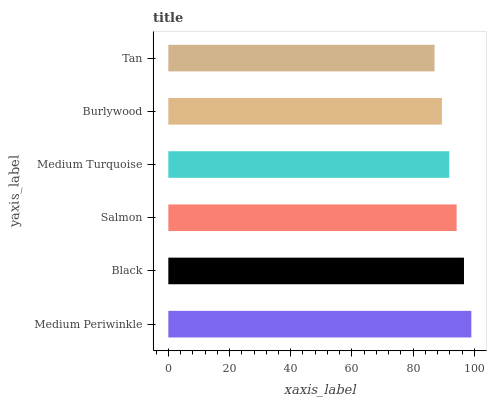Is Tan the minimum?
Answer yes or no. Yes. Is Medium Periwinkle the maximum?
Answer yes or no. Yes. Is Black the minimum?
Answer yes or no. No. Is Black the maximum?
Answer yes or no. No. Is Medium Periwinkle greater than Black?
Answer yes or no. Yes. Is Black less than Medium Periwinkle?
Answer yes or no. Yes. Is Black greater than Medium Periwinkle?
Answer yes or no. No. Is Medium Periwinkle less than Black?
Answer yes or no. No. Is Salmon the high median?
Answer yes or no. Yes. Is Medium Turquoise the low median?
Answer yes or no. Yes. Is Burlywood the high median?
Answer yes or no. No. Is Black the low median?
Answer yes or no. No. 